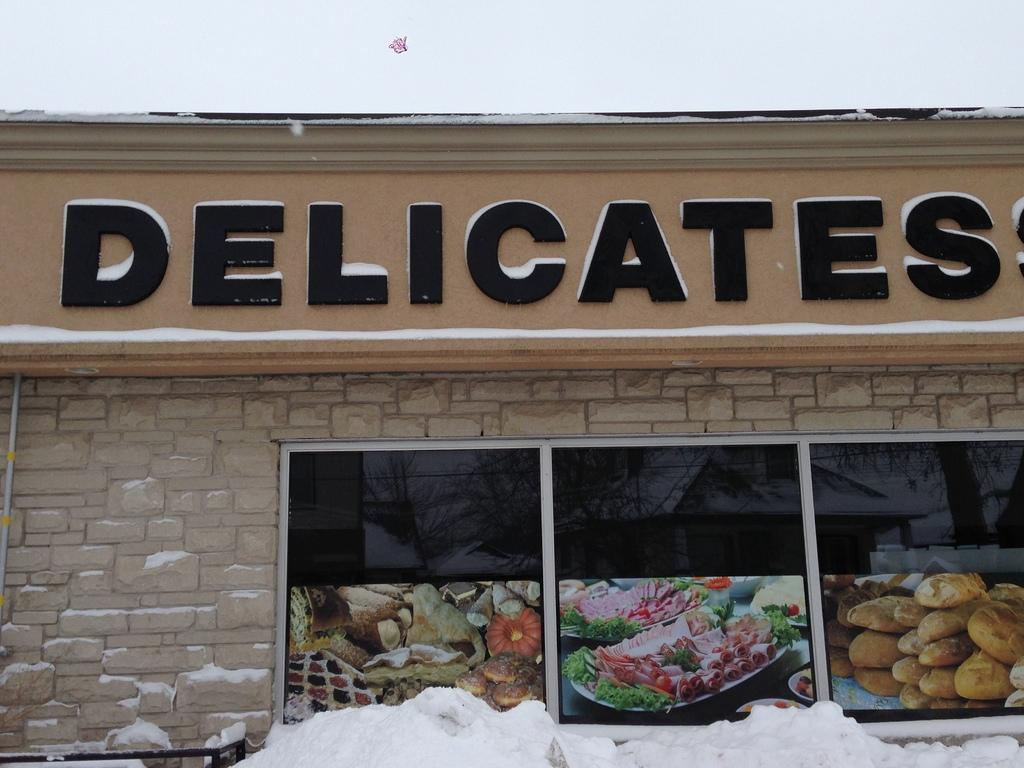What is the main structure in the picture? There is a building in the picture. Is there any text or image on the building? Yes, there is a nameplate on the building. What is depicted on the nameplate? The nameplate has pictures of food. What is the condition of the ground in the picture? There is snow on the floor in the picture. Can you see a fan spinning in the picture? There is no fan present in the image. What type of train can be seen passing by the building in the picture? There is no train visible in the image; it only features a building with a nameplate and snow on the ground. 